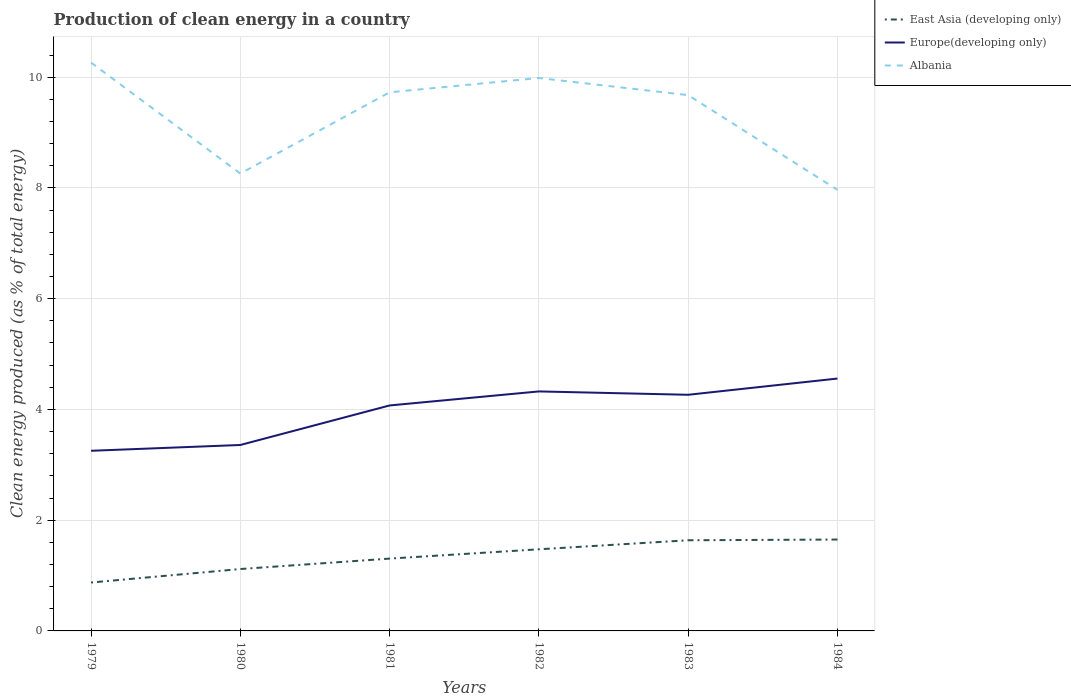Across all years, what is the maximum percentage of clean energy produced in Europe(developing only)?
Ensure brevity in your answer.  3.25. In which year was the percentage of clean energy produced in Europe(developing only) maximum?
Keep it short and to the point. 1979. What is the total percentage of clean energy produced in Europe(developing only) in the graph?
Give a very brief answer. -0.71. What is the difference between the highest and the second highest percentage of clean energy produced in Albania?
Your response must be concise. 2.3. Is the percentage of clean energy produced in Europe(developing only) strictly greater than the percentage of clean energy produced in East Asia (developing only) over the years?
Provide a succinct answer. No. How many lines are there?
Your response must be concise. 3. Does the graph contain grids?
Give a very brief answer. Yes. Where does the legend appear in the graph?
Provide a short and direct response. Top right. What is the title of the graph?
Make the answer very short. Production of clean energy in a country. Does "Turks and Caicos Islands" appear as one of the legend labels in the graph?
Provide a succinct answer. No. What is the label or title of the Y-axis?
Provide a succinct answer. Clean energy produced (as % of total energy). What is the Clean energy produced (as % of total energy) of East Asia (developing only) in 1979?
Make the answer very short. 0.87. What is the Clean energy produced (as % of total energy) of Europe(developing only) in 1979?
Give a very brief answer. 3.25. What is the Clean energy produced (as % of total energy) in Albania in 1979?
Keep it short and to the point. 10.26. What is the Clean energy produced (as % of total energy) of East Asia (developing only) in 1980?
Your answer should be very brief. 1.12. What is the Clean energy produced (as % of total energy) of Europe(developing only) in 1980?
Provide a short and direct response. 3.36. What is the Clean energy produced (as % of total energy) in Albania in 1980?
Ensure brevity in your answer.  8.26. What is the Clean energy produced (as % of total energy) in East Asia (developing only) in 1981?
Your response must be concise. 1.31. What is the Clean energy produced (as % of total energy) in Europe(developing only) in 1981?
Offer a very short reply. 4.07. What is the Clean energy produced (as % of total energy) in Albania in 1981?
Your answer should be compact. 9.73. What is the Clean energy produced (as % of total energy) of East Asia (developing only) in 1982?
Offer a very short reply. 1.47. What is the Clean energy produced (as % of total energy) of Europe(developing only) in 1982?
Your response must be concise. 4.33. What is the Clean energy produced (as % of total energy) in Albania in 1982?
Offer a terse response. 9.99. What is the Clean energy produced (as % of total energy) in East Asia (developing only) in 1983?
Offer a very short reply. 1.64. What is the Clean energy produced (as % of total energy) of Europe(developing only) in 1983?
Ensure brevity in your answer.  4.26. What is the Clean energy produced (as % of total energy) of Albania in 1983?
Give a very brief answer. 9.68. What is the Clean energy produced (as % of total energy) of East Asia (developing only) in 1984?
Give a very brief answer. 1.65. What is the Clean energy produced (as % of total energy) in Europe(developing only) in 1984?
Keep it short and to the point. 4.56. What is the Clean energy produced (as % of total energy) of Albania in 1984?
Offer a terse response. 7.96. Across all years, what is the maximum Clean energy produced (as % of total energy) in East Asia (developing only)?
Your response must be concise. 1.65. Across all years, what is the maximum Clean energy produced (as % of total energy) of Europe(developing only)?
Offer a terse response. 4.56. Across all years, what is the maximum Clean energy produced (as % of total energy) in Albania?
Offer a terse response. 10.26. Across all years, what is the minimum Clean energy produced (as % of total energy) in East Asia (developing only)?
Offer a terse response. 0.87. Across all years, what is the minimum Clean energy produced (as % of total energy) in Europe(developing only)?
Provide a short and direct response. 3.25. Across all years, what is the minimum Clean energy produced (as % of total energy) in Albania?
Provide a succinct answer. 7.96. What is the total Clean energy produced (as % of total energy) in East Asia (developing only) in the graph?
Provide a succinct answer. 8.06. What is the total Clean energy produced (as % of total energy) in Europe(developing only) in the graph?
Ensure brevity in your answer.  23.83. What is the total Clean energy produced (as % of total energy) in Albania in the graph?
Keep it short and to the point. 55.88. What is the difference between the Clean energy produced (as % of total energy) of East Asia (developing only) in 1979 and that in 1980?
Offer a terse response. -0.24. What is the difference between the Clean energy produced (as % of total energy) of Europe(developing only) in 1979 and that in 1980?
Make the answer very short. -0.1. What is the difference between the Clean energy produced (as % of total energy) of Albania in 1979 and that in 1980?
Make the answer very short. 2. What is the difference between the Clean energy produced (as % of total energy) in East Asia (developing only) in 1979 and that in 1981?
Make the answer very short. -0.43. What is the difference between the Clean energy produced (as % of total energy) in Europe(developing only) in 1979 and that in 1981?
Ensure brevity in your answer.  -0.82. What is the difference between the Clean energy produced (as % of total energy) of Albania in 1979 and that in 1981?
Provide a succinct answer. 0.54. What is the difference between the Clean energy produced (as % of total energy) of East Asia (developing only) in 1979 and that in 1982?
Your answer should be very brief. -0.6. What is the difference between the Clean energy produced (as % of total energy) in Europe(developing only) in 1979 and that in 1982?
Give a very brief answer. -1.07. What is the difference between the Clean energy produced (as % of total energy) of Albania in 1979 and that in 1982?
Provide a short and direct response. 0.28. What is the difference between the Clean energy produced (as % of total energy) in East Asia (developing only) in 1979 and that in 1983?
Keep it short and to the point. -0.76. What is the difference between the Clean energy produced (as % of total energy) of Europe(developing only) in 1979 and that in 1983?
Provide a succinct answer. -1.01. What is the difference between the Clean energy produced (as % of total energy) in Albania in 1979 and that in 1983?
Offer a very short reply. 0.59. What is the difference between the Clean energy produced (as % of total energy) in East Asia (developing only) in 1979 and that in 1984?
Your response must be concise. -0.78. What is the difference between the Clean energy produced (as % of total energy) of Europe(developing only) in 1979 and that in 1984?
Your response must be concise. -1.3. What is the difference between the Clean energy produced (as % of total energy) in Albania in 1979 and that in 1984?
Make the answer very short. 2.3. What is the difference between the Clean energy produced (as % of total energy) in East Asia (developing only) in 1980 and that in 1981?
Your response must be concise. -0.19. What is the difference between the Clean energy produced (as % of total energy) of Europe(developing only) in 1980 and that in 1981?
Keep it short and to the point. -0.71. What is the difference between the Clean energy produced (as % of total energy) of Albania in 1980 and that in 1981?
Ensure brevity in your answer.  -1.47. What is the difference between the Clean energy produced (as % of total energy) in East Asia (developing only) in 1980 and that in 1982?
Give a very brief answer. -0.36. What is the difference between the Clean energy produced (as % of total energy) of Europe(developing only) in 1980 and that in 1982?
Your response must be concise. -0.97. What is the difference between the Clean energy produced (as % of total energy) of Albania in 1980 and that in 1982?
Offer a terse response. -1.73. What is the difference between the Clean energy produced (as % of total energy) of East Asia (developing only) in 1980 and that in 1983?
Your response must be concise. -0.52. What is the difference between the Clean energy produced (as % of total energy) of Europe(developing only) in 1980 and that in 1983?
Your answer should be very brief. -0.91. What is the difference between the Clean energy produced (as % of total energy) in Albania in 1980 and that in 1983?
Make the answer very short. -1.42. What is the difference between the Clean energy produced (as % of total energy) in East Asia (developing only) in 1980 and that in 1984?
Your answer should be compact. -0.53. What is the difference between the Clean energy produced (as % of total energy) of Albania in 1980 and that in 1984?
Provide a short and direct response. 0.29. What is the difference between the Clean energy produced (as % of total energy) in East Asia (developing only) in 1981 and that in 1982?
Make the answer very short. -0.17. What is the difference between the Clean energy produced (as % of total energy) of Europe(developing only) in 1981 and that in 1982?
Offer a terse response. -0.25. What is the difference between the Clean energy produced (as % of total energy) in Albania in 1981 and that in 1982?
Offer a very short reply. -0.26. What is the difference between the Clean energy produced (as % of total energy) in East Asia (developing only) in 1981 and that in 1983?
Offer a very short reply. -0.33. What is the difference between the Clean energy produced (as % of total energy) of Europe(developing only) in 1981 and that in 1983?
Your answer should be compact. -0.19. What is the difference between the Clean energy produced (as % of total energy) of Albania in 1981 and that in 1983?
Provide a succinct answer. 0.05. What is the difference between the Clean energy produced (as % of total energy) of East Asia (developing only) in 1981 and that in 1984?
Give a very brief answer. -0.34. What is the difference between the Clean energy produced (as % of total energy) in Europe(developing only) in 1981 and that in 1984?
Ensure brevity in your answer.  -0.49. What is the difference between the Clean energy produced (as % of total energy) in Albania in 1981 and that in 1984?
Provide a succinct answer. 1.76. What is the difference between the Clean energy produced (as % of total energy) of East Asia (developing only) in 1982 and that in 1983?
Keep it short and to the point. -0.16. What is the difference between the Clean energy produced (as % of total energy) of Europe(developing only) in 1982 and that in 1983?
Provide a short and direct response. 0.06. What is the difference between the Clean energy produced (as % of total energy) in Albania in 1982 and that in 1983?
Make the answer very short. 0.31. What is the difference between the Clean energy produced (as % of total energy) in East Asia (developing only) in 1982 and that in 1984?
Your response must be concise. -0.18. What is the difference between the Clean energy produced (as % of total energy) of Europe(developing only) in 1982 and that in 1984?
Give a very brief answer. -0.23. What is the difference between the Clean energy produced (as % of total energy) in Albania in 1982 and that in 1984?
Provide a short and direct response. 2.02. What is the difference between the Clean energy produced (as % of total energy) in East Asia (developing only) in 1983 and that in 1984?
Provide a succinct answer. -0.01. What is the difference between the Clean energy produced (as % of total energy) in Europe(developing only) in 1983 and that in 1984?
Provide a succinct answer. -0.29. What is the difference between the Clean energy produced (as % of total energy) of Albania in 1983 and that in 1984?
Provide a short and direct response. 1.71. What is the difference between the Clean energy produced (as % of total energy) in East Asia (developing only) in 1979 and the Clean energy produced (as % of total energy) in Europe(developing only) in 1980?
Your answer should be compact. -2.48. What is the difference between the Clean energy produced (as % of total energy) in East Asia (developing only) in 1979 and the Clean energy produced (as % of total energy) in Albania in 1980?
Provide a succinct answer. -7.39. What is the difference between the Clean energy produced (as % of total energy) of Europe(developing only) in 1979 and the Clean energy produced (as % of total energy) of Albania in 1980?
Your answer should be compact. -5.01. What is the difference between the Clean energy produced (as % of total energy) of East Asia (developing only) in 1979 and the Clean energy produced (as % of total energy) of Europe(developing only) in 1981?
Your response must be concise. -3.2. What is the difference between the Clean energy produced (as % of total energy) in East Asia (developing only) in 1979 and the Clean energy produced (as % of total energy) in Albania in 1981?
Make the answer very short. -8.85. What is the difference between the Clean energy produced (as % of total energy) of Europe(developing only) in 1979 and the Clean energy produced (as % of total energy) of Albania in 1981?
Give a very brief answer. -6.47. What is the difference between the Clean energy produced (as % of total energy) of East Asia (developing only) in 1979 and the Clean energy produced (as % of total energy) of Europe(developing only) in 1982?
Make the answer very short. -3.45. What is the difference between the Clean energy produced (as % of total energy) in East Asia (developing only) in 1979 and the Clean energy produced (as % of total energy) in Albania in 1982?
Offer a terse response. -9.11. What is the difference between the Clean energy produced (as % of total energy) in Europe(developing only) in 1979 and the Clean energy produced (as % of total energy) in Albania in 1982?
Make the answer very short. -6.73. What is the difference between the Clean energy produced (as % of total energy) in East Asia (developing only) in 1979 and the Clean energy produced (as % of total energy) in Europe(developing only) in 1983?
Your response must be concise. -3.39. What is the difference between the Clean energy produced (as % of total energy) of East Asia (developing only) in 1979 and the Clean energy produced (as % of total energy) of Albania in 1983?
Offer a terse response. -8.8. What is the difference between the Clean energy produced (as % of total energy) in Europe(developing only) in 1979 and the Clean energy produced (as % of total energy) in Albania in 1983?
Provide a succinct answer. -6.42. What is the difference between the Clean energy produced (as % of total energy) of East Asia (developing only) in 1979 and the Clean energy produced (as % of total energy) of Europe(developing only) in 1984?
Offer a very short reply. -3.68. What is the difference between the Clean energy produced (as % of total energy) of East Asia (developing only) in 1979 and the Clean energy produced (as % of total energy) of Albania in 1984?
Your answer should be very brief. -7.09. What is the difference between the Clean energy produced (as % of total energy) of Europe(developing only) in 1979 and the Clean energy produced (as % of total energy) of Albania in 1984?
Provide a succinct answer. -4.71. What is the difference between the Clean energy produced (as % of total energy) in East Asia (developing only) in 1980 and the Clean energy produced (as % of total energy) in Europe(developing only) in 1981?
Provide a short and direct response. -2.95. What is the difference between the Clean energy produced (as % of total energy) of East Asia (developing only) in 1980 and the Clean energy produced (as % of total energy) of Albania in 1981?
Give a very brief answer. -8.61. What is the difference between the Clean energy produced (as % of total energy) in Europe(developing only) in 1980 and the Clean energy produced (as % of total energy) in Albania in 1981?
Ensure brevity in your answer.  -6.37. What is the difference between the Clean energy produced (as % of total energy) of East Asia (developing only) in 1980 and the Clean energy produced (as % of total energy) of Europe(developing only) in 1982?
Offer a very short reply. -3.21. What is the difference between the Clean energy produced (as % of total energy) of East Asia (developing only) in 1980 and the Clean energy produced (as % of total energy) of Albania in 1982?
Your answer should be compact. -8.87. What is the difference between the Clean energy produced (as % of total energy) of Europe(developing only) in 1980 and the Clean energy produced (as % of total energy) of Albania in 1982?
Provide a succinct answer. -6.63. What is the difference between the Clean energy produced (as % of total energy) of East Asia (developing only) in 1980 and the Clean energy produced (as % of total energy) of Europe(developing only) in 1983?
Make the answer very short. -3.15. What is the difference between the Clean energy produced (as % of total energy) in East Asia (developing only) in 1980 and the Clean energy produced (as % of total energy) in Albania in 1983?
Make the answer very short. -8.56. What is the difference between the Clean energy produced (as % of total energy) in Europe(developing only) in 1980 and the Clean energy produced (as % of total energy) in Albania in 1983?
Your answer should be very brief. -6.32. What is the difference between the Clean energy produced (as % of total energy) in East Asia (developing only) in 1980 and the Clean energy produced (as % of total energy) in Europe(developing only) in 1984?
Make the answer very short. -3.44. What is the difference between the Clean energy produced (as % of total energy) in East Asia (developing only) in 1980 and the Clean energy produced (as % of total energy) in Albania in 1984?
Provide a short and direct response. -6.85. What is the difference between the Clean energy produced (as % of total energy) of Europe(developing only) in 1980 and the Clean energy produced (as % of total energy) of Albania in 1984?
Make the answer very short. -4.61. What is the difference between the Clean energy produced (as % of total energy) of East Asia (developing only) in 1981 and the Clean energy produced (as % of total energy) of Europe(developing only) in 1982?
Make the answer very short. -3.02. What is the difference between the Clean energy produced (as % of total energy) in East Asia (developing only) in 1981 and the Clean energy produced (as % of total energy) in Albania in 1982?
Keep it short and to the point. -8.68. What is the difference between the Clean energy produced (as % of total energy) of Europe(developing only) in 1981 and the Clean energy produced (as % of total energy) of Albania in 1982?
Provide a succinct answer. -5.91. What is the difference between the Clean energy produced (as % of total energy) of East Asia (developing only) in 1981 and the Clean energy produced (as % of total energy) of Europe(developing only) in 1983?
Provide a succinct answer. -2.96. What is the difference between the Clean energy produced (as % of total energy) in East Asia (developing only) in 1981 and the Clean energy produced (as % of total energy) in Albania in 1983?
Provide a short and direct response. -8.37. What is the difference between the Clean energy produced (as % of total energy) in Europe(developing only) in 1981 and the Clean energy produced (as % of total energy) in Albania in 1983?
Give a very brief answer. -5.6. What is the difference between the Clean energy produced (as % of total energy) in East Asia (developing only) in 1981 and the Clean energy produced (as % of total energy) in Europe(developing only) in 1984?
Your response must be concise. -3.25. What is the difference between the Clean energy produced (as % of total energy) in East Asia (developing only) in 1981 and the Clean energy produced (as % of total energy) in Albania in 1984?
Your answer should be very brief. -6.66. What is the difference between the Clean energy produced (as % of total energy) in Europe(developing only) in 1981 and the Clean energy produced (as % of total energy) in Albania in 1984?
Give a very brief answer. -3.89. What is the difference between the Clean energy produced (as % of total energy) of East Asia (developing only) in 1982 and the Clean energy produced (as % of total energy) of Europe(developing only) in 1983?
Keep it short and to the point. -2.79. What is the difference between the Clean energy produced (as % of total energy) of East Asia (developing only) in 1982 and the Clean energy produced (as % of total energy) of Albania in 1983?
Provide a short and direct response. -8.2. What is the difference between the Clean energy produced (as % of total energy) in Europe(developing only) in 1982 and the Clean energy produced (as % of total energy) in Albania in 1983?
Your answer should be compact. -5.35. What is the difference between the Clean energy produced (as % of total energy) of East Asia (developing only) in 1982 and the Clean energy produced (as % of total energy) of Europe(developing only) in 1984?
Give a very brief answer. -3.08. What is the difference between the Clean energy produced (as % of total energy) of East Asia (developing only) in 1982 and the Clean energy produced (as % of total energy) of Albania in 1984?
Offer a terse response. -6.49. What is the difference between the Clean energy produced (as % of total energy) in Europe(developing only) in 1982 and the Clean energy produced (as % of total energy) in Albania in 1984?
Make the answer very short. -3.64. What is the difference between the Clean energy produced (as % of total energy) in East Asia (developing only) in 1983 and the Clean energy produced (as % of total energy) in Europe(developing only) in 1984?
Offer a very short reply. -2.92. What is the difference between the Clean energy produced (as % of total energy) in East Asia (developing only) in 1983 and the Clean energy produced (as % of total energy) in Albania in 1984?
Provide a short and direct response. -6.33. What is the difference between the Clean energy produced (as % of total energy) in Europe(developing only) in 1983 and the Clean energy produced (as % of total energy) in Albania in 1984?
Ensure brevity in your answer.  -3.7. What is the average Clean energy produced (as % of total energy) of East Asia (developing only) per year?
Make the answer very short. 1.34. What is the average Clean energy produced (as % of total energy) of Europe(developing only) per year?
Your answer should be very brief. 3.97. What is the average Clean energy produced (as % of total energy) of Albania per year?
Keep it short and to the point. 9.31. In the year 1979, what is the difference between the Clean energy produced (as % of total energy) in East Asia (developing only) and Clean energy produced (as % of total energy) in Europe(developing only)?
Offer a very short reply. -2.38. In the year 1979, what is the difference between the Clean energy produced (as % of total energy) of East Asia (developing only) and Clean energy produced (as % of total energy) of Albania?
Your answer should be very brief. -9.39. In the year 1979, what is the difference between the Clean energy produced (as % of total energy) of Europe(developing only) and Clean energy produced (as % of total energy) of Albania?
Give a very brief answer. -7.01. In the year 1980, what is the difference between the Clean energy produced (as % of total energy) of East Asia (developing only) and Clean energy produced (as % of total energy) of Europe(developing only)?
Provide a succinct answer. -2.24. In the year 1980, what is the difference between the Clean energy produced (as % of total energy) in East Asia (developing only) and Clean energy produced (as % of total energy) in Albania?
Offer a very short reply. -7.14. In the year 1980, what is the difference between the Clean energy produced (as % of total energy) of Europe(developing only) and Clean energy produced (as % of total energy) of Albania?
Your answer should be very brief. -4.9. In the year 1981, what is the difference between the Clean energy produced (as % of total energy) of East Asia (developing only) and Clean energy produced (as % of total energy) of Europe(developing only)?
Give a very brief answer. -2.77. In the year 1981, what is the difference between the Clean energy produced (as % of total energy) in East Asia (developing only) and Clean energy produced (as % of total energy) in Albania?
Your response must be concise. -8.42. In the year 1981, what is the difference between the Clean energy produced (as % of total energy) in Europe(developing only) and Clean energy produced (as % of total energy) in Albania?
Give a very brief answer. -5.66. In the year 1982, what is the difference between the Clean energy produced (as % of total energy) in East Asia (developing only) and Clean energy produced (as % of total energy) in Europe(developing only)?
Offer a very short reply. -2.85. In the year 1982, what is the difference between the Clean energy produced (as % of total energy) of East Asia (developing only) and Clean energy produced (as % of total energy) of Albania?
Make the answer very short. -8.51. In the year 1982, what is the difference between the Clean energy produced (as % of total energy) in Europe(developing only) and Clean energy produced (as % of total energy) in Albania?
Offer a terse response. -5.66. In the year 1983, what is the difference between the Clean energy produced (as % of total energy) of East Asia (developing only) and Clean energy produced (as % of total energy) of Europe(developing only)?
Offer a terse response. -2.63. In the year 1983, what is the difference between the Clean energy produced (as % of total energy) of East Asia (developing only) and Clean energy produced (as % of total energy) of Albania?
Make the answer very short. -8.04. In the year 1983, what is the difference between the Clean energy produced (as % of total energy) in Europe(developing only) and Clean energy produced (as % of total energy) in Albania?
Provide a succinct answer. -5.41. In the year 1984, what is the difference between the Clean energy produced (as % of total energy) of East Asia (developing only) and Clean energy produced (as % of total energy) of Europe(developing only)?
Your answer should be very brief. -2.91. In the year 1984, what is the difference between the Clean energy produced (as % of total energy) of East Asia (developing only) and Clean energy produced (as % of total energy) of Albania?
Your response must be concise. -6.31. In the year 1984, what is the difference between the Clean energy produced (as % of total energy) of Europe(developing only) and Clean energy produced (as % of total energy) of Albania?
Give a very brief answer. -3.41. What is the ratio of the Clean energy produced (as % of total energy) of East Asia (developing only) in 1979 to that in 1980?
Your answer should be compact. 0.78. What is the ratio of the Clean energy produced (as % of total energy) in Europe(developing only) in 1979 to that in 1980?
Give a very brief answer. 0.97. What is the ratio of the Clean energy produced (as % of total energy) in Albania in 1979 to that in 1980?
Keep it short and to the point. 1.24. What is the ratio of the Clean energy produced (as % of total energy) in East Asia (developing only) in 1979 to that in 1981?
Ensure brevity in your answer.  0.67. What is the ratio of the Clean energy produced (as % of total energy) of Europe(developing only) in 1979 to that in 1981?
Offer a terse response. 0.8. What is the ratio of the Clean energy produced (as % of total energy) of Albania in 1979 to that in 1981?
Your answer should be compact. 1.06. What is the ratio of the Clean energy produced (as % of total energy) of East Asia (developing only) in 1979 to that in 1982?
Provide a succinct answer. 0.59. What is the ratio of the Clean energy produced (as % of total energy) in Europe(developing only) in 1979 to that in 1982?
Provide a short and direct response. 0.75. What is the ratio of the Clean energy produced (as % of total energy) of Albania in 1979 to that in 1982?
Offer a terse response. 1.03. What is the ratio of the Clean energy produced (as % of total energy) of East Asia (developing only) in 1979 to that in 1983?
Make the answer very short. 0.53. What is the ratio of the Clean energy produced (as % of total energy) of Europe(developing only) in 1979 to that in 1983?
Your answer should be very brief. 0.76. What is the ratio of the Clean energy produced (as % of total energy) in Albania in 1979 to that in 1983?
Provide a short and direct response. 1.06. What is the ratio of the Clean energy produced (as % of total energy) of East Asia (developing only) in 1979 to that in 1984?
Give a very brief answer. 0.53. What is the ratio of the Clean energy produced (as % of total energy) of Europe(developing only) in 1979 to that in 1984?
Ensure brevity in your answer.  0.71. What is the ratio of the Clean energy produced (as % of total energy) in Albania in 1979 to that in 1984?
Keep it short and to the point. 1.29. What is the ratio of the Clean energy produced (as % of total energy) of East Asia (developing only) in 1980 to that in 1981?
Ensure brevity in your answer.  0.86. What is the ratio of the Clean energy produced (as % of total energy) of Europe(developing only) in 1980 to that in 1981?
Ensure brevity in your answer.  0.82. What is the ratio of the Clean energy produced (as % of total energy) of Albania in 1980 to that in 1981?
Your answer should be compact. 0.85. What is the ratio of the Clean energy produced (as % of total energy) of East Asia (developing only) in 1980 to that in 1982?
Your response must be concise. 0.76. What is the ratio of the Clean energy produced (as % of total energy) of Europe(developing only) in 1980 to that in 1982?
Your response must be concise. 0.78. What is the ratio of the Clean energy produced (as % of total energy) in Albania in 1980 to that in 1982?
Ensure brevity in your answer.  0.83. What is the ratio of the Clean energy produced (as % of total energy) of East Asia (developing only) in 1980 to that in 1983?
Give a very brief answer. 0.68. What is the ratio of the Clean energy produced (as % of total energy) in Europe(developing only) in 1980 to that in 1983?
Keep it short and to the point. 0.79. What is the ratio of the Clean energy produced (as % of total energy) in Albania in 1980 to that in 1983?
Your answer should be very brief. 0.85. What is the ratio of the Clean energy produced (as % of total energy) of East Asia (developing only) in 1980 to that in 1984?
Provide a short and direct response. 0.68. What is the ratio of the Clean energy produced (as % of total energy) of Europe(developing only) in 1980 to that in 1984?
Keep it short and to the point. 0.74. What is the ratio of the Clean energy produced (as % of total energy) of East Asia (developing only) in 1981 to that in 1982?
Ensure brevity in your answer.  0.89. What is the ratio of the Clean energy produced (as % of total energy) in Europe(developing only) in 1981 to that in 1982?
Make the answer very short. 0.94. What is the ratio of the Clean energy produced (as % of total energy) of Albania in 1981 to that in 1982?
Give a very brief answer. 0.97. What is the ratio of the Clean energy produced (as % of total energy) in East Asia (developing only) in 1981 to that in 1983?
Provide a succinct answer. 0.8. What is the ratio of the Clean energy produced (as % of total energy) of Europe(developing only) in 1981 to that in 1983?
Keep it short and to the point. 0.95. What is the ratio of the Clean energy produced (as % of total energy) of Albania in 1981 to that in 1983?
Your response must be concise. 1.01. What is the ratio of the Clean energy produced (as % of total energy) in East Asia (developing only) in 1981 to that in 1984?
Offer a terse response. 0.79. What is the ratio of the Clean energy produced (as % of total energy) of Europe(developing only) in 1981 to that in 1984?
Provide a short and direct response. 0.89. What is the ratio of the Clean energy produced (as % of total energy) of Albania in 1981 to that in 1984?
Provide a succinct answer. 1.22. What is the ratio of the Clean energy produced (as % of total energy) in East Asia (developing only) in 1982 to that in 1983?
Your answer should be very brief. 0.9. What is the ratio of the Clean energy produced (as % of total energy) in Europe(developing only) in 1982 to that in 1983?
Your response must be concise. 1.01. What is the ratio of the Clean energy produced (as % of total energy) of Albania in 1982 to that in 1983?
Your answer should be compact. 1.03. What is the ratio of the Clean energy produced (as % of total energy) in East Asia (developing only) in 1982 to that in 1984?
Give a very brief answer. 0.89. What is the ratio of the Clean energy produced (as % of total energy) of Europe(developing only) in 1982 to that in 1984?
Provide a short and direct response. 0.95. What is the ratio of the Clean energy produced (as % of total energy) in Albania in 1982 to that in 1984?
Provide a short and direct response. 1.25. What is the ratio of the Clean energy produced (as % of total energy) in Europe(developing only) in 1983 to that in 1984?
Your answer should be compact. 0.94. What is the ratio of the Clean energy produced (as % of total energy) in Albania in 1983 to that in 1984?
Provide a succinct answer. 1.21. What is the difference between the highest and the second highest Clean energy produced (as % of total energy) of East Asia (developing only)?
Ensure brevity in your answer.  0.01. What is the difference between the highest and the second highest Clean energy produced (as % of total energy) in Europe(developing only)?
Provide a succinct answer. 0.23. What is the difference between the highest and the second highest Clean energy produced (as % of total energy) in Albania?
Your answer should be compact. 0.28. What is the difference between the highest and the lowest Clean energy produced (as % of total energy) of East Asia (developing only)?
Provide a short and direct response. 0.78. What is the difference between the highest and the lowest Clean energy produced (as % of total energy) in Europe(developing only)?
Provide a short and direct response. 1.3. What is the difference between the highest and the lowest Clean energy produced (as % of total energy) of Albania?
Make the answer very short. 2.3. 